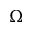Convert formula to latex. <formula><loc_0><loc_0><loc_500><loc_500>\Omega</formula> 